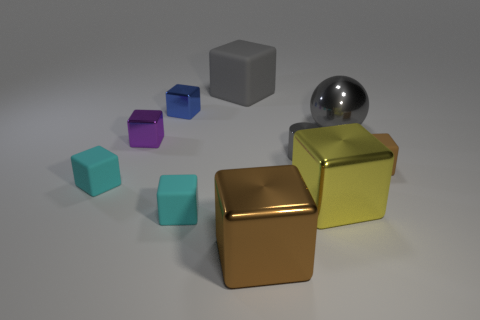What material is the small brown object that is the same shape as the big yellow thing?
Make the answer very short. Rubber. There is a sphere that is the same material as the yellow thing; what is its color?
Your response must be concise. Gray. What number of small things are both right of the small blue metallic thing and in front of the tiny gray object?
Keep it short and to the point. 2. Does the tiny blue block have the same material as the big yellow block?
Your answer should be compact. Yes. There is a blue thing that is the same size as the purple shiny object; what is its shape?
Ensure brevity in your answer.  Cube. What is the cube that is behind the tiny gray metal cylinder and to the left of the small blue metal thing made of?
Keep it short and to the point. Metal. What number of other things are there of the same material as the small brown cube
Provide a short and direct response. 3. What size is the cube that is in front of the cyan object in front of the cyan rubber thing that is left of the blue thing?
Offer a terse response. Large. There is a blue object; is it the same shape as the brown thing that is on the right side of the metal sphere?
Your answer should be very brief. Yes. Are there more big brown things that are in front of the tiny gray cylinder than tiny blue blocks in front of the tiny brown block?
Ensure brevity in your answer.  Yes. 